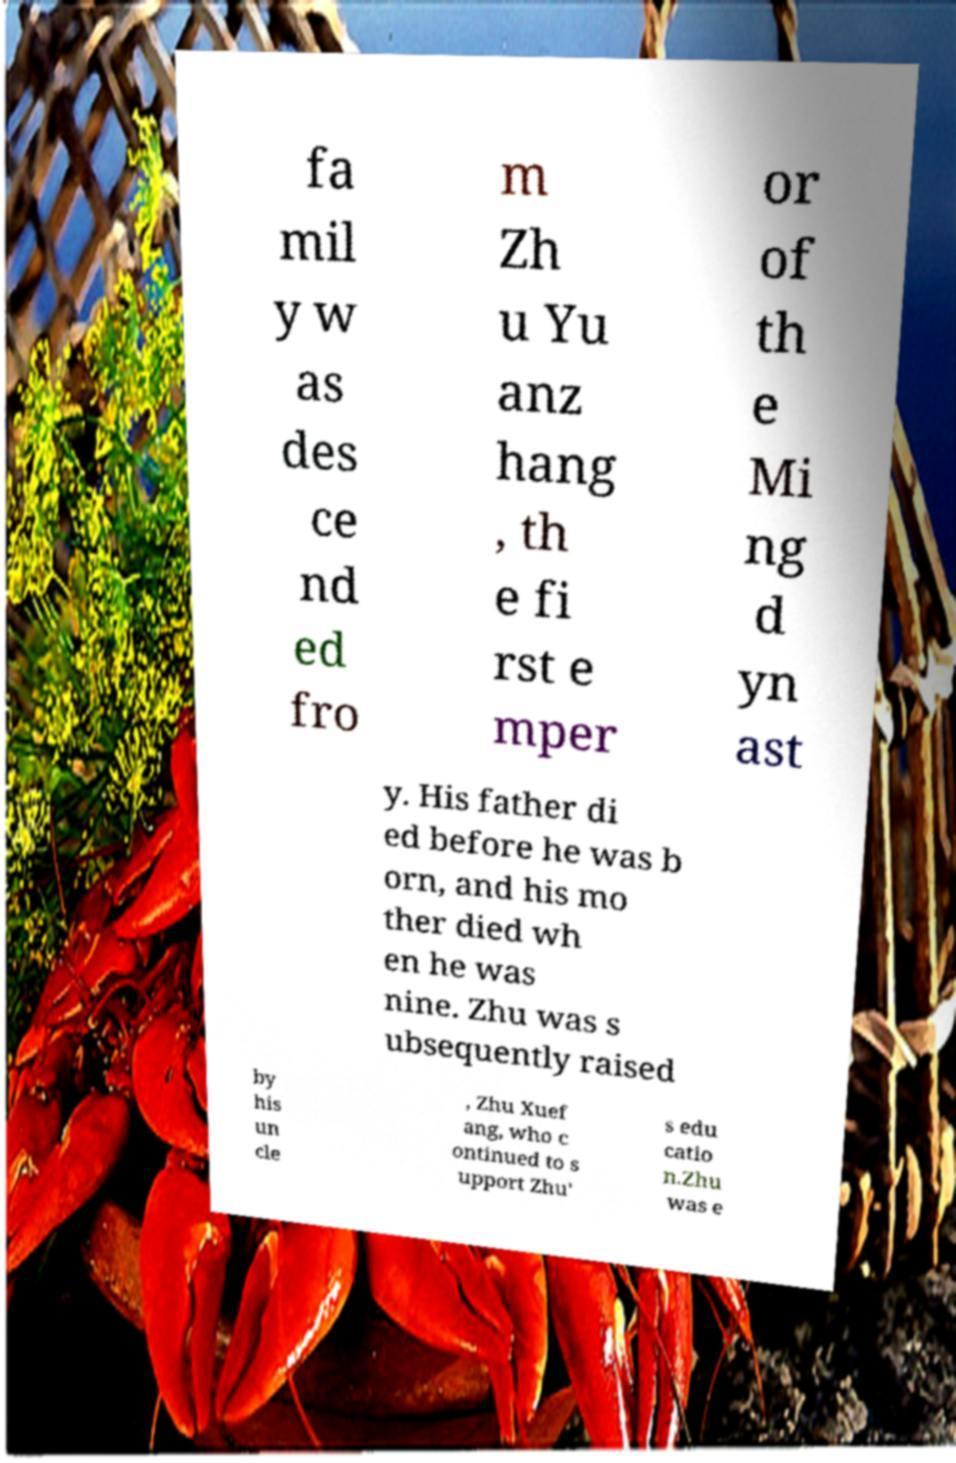What messages or text are displayed in this image? I need them in a readable, typed format. fa mil y w as des ce nd ed fro m Zh u Yu anz hang , th e fi rst e mper or of th e Mi ng d yn ast y. His father di ed before he was b orn, and his mo ther died wh en he was nine. Zhu was s ubsequently raised by his un cle , Zhu Xuef ang, who c ontinued to s upport Zhu' s edu catio n.Zhu was e 